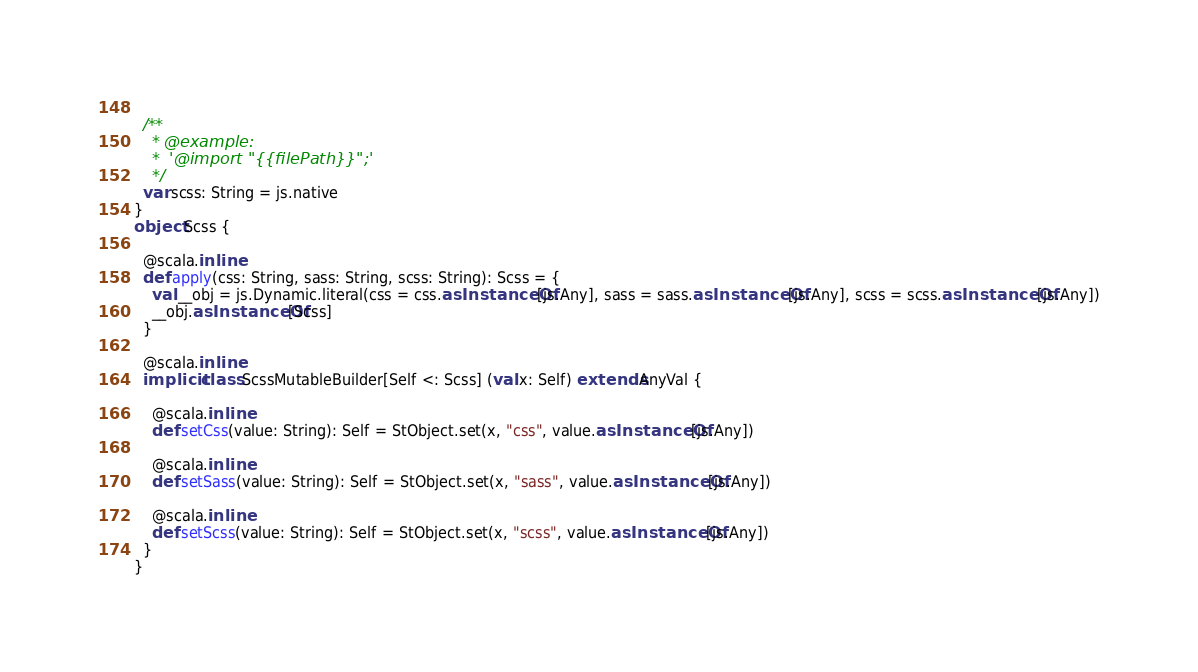Convert code to text. <code><loc_0><loc_0><loc_500><loc_500><_Scala_>  
  /**
    * @example:
    *  '@import "{{filePath}}";'
    */
  var scss: String = js.native
}
object Scss {
  
  @scala.inline
  def apply(css: String, sass: String, scss: String): Scss = {
    val __obj = js.Dynamic.literal(css = css.asInstanceOf[js.Any], sass = sass.asInstanceOf[js.Any], scss = scss.asInstanceOf[js.Any])
    __obj.asInstanceOf[Scss]
  }
  
  @scala.inline
  implicit class ScssMutableBuilder[Self <: Scss] (val x: Self) extends AnyVal {
    
    @scala.inline
    def setCss(value: String): Self = StObject.set(x, "css", value.asInstanceOf[js.Any])
    
    @scala.inline
    def setSass(value: String): Self = StObject.set(x, "sass", value.asInstanceOf[js.Any])
    
    @scala.inline
    def setScss(value: String): Self = StObject.set(x, "scss", value.asInstanceOf[js.Any])
  }
}
</code> 